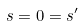Convert formula to latex. <formula><loc_0><loc_0><loc_500><loc_500>s = 0 = s ^ { \prime }</formula> 